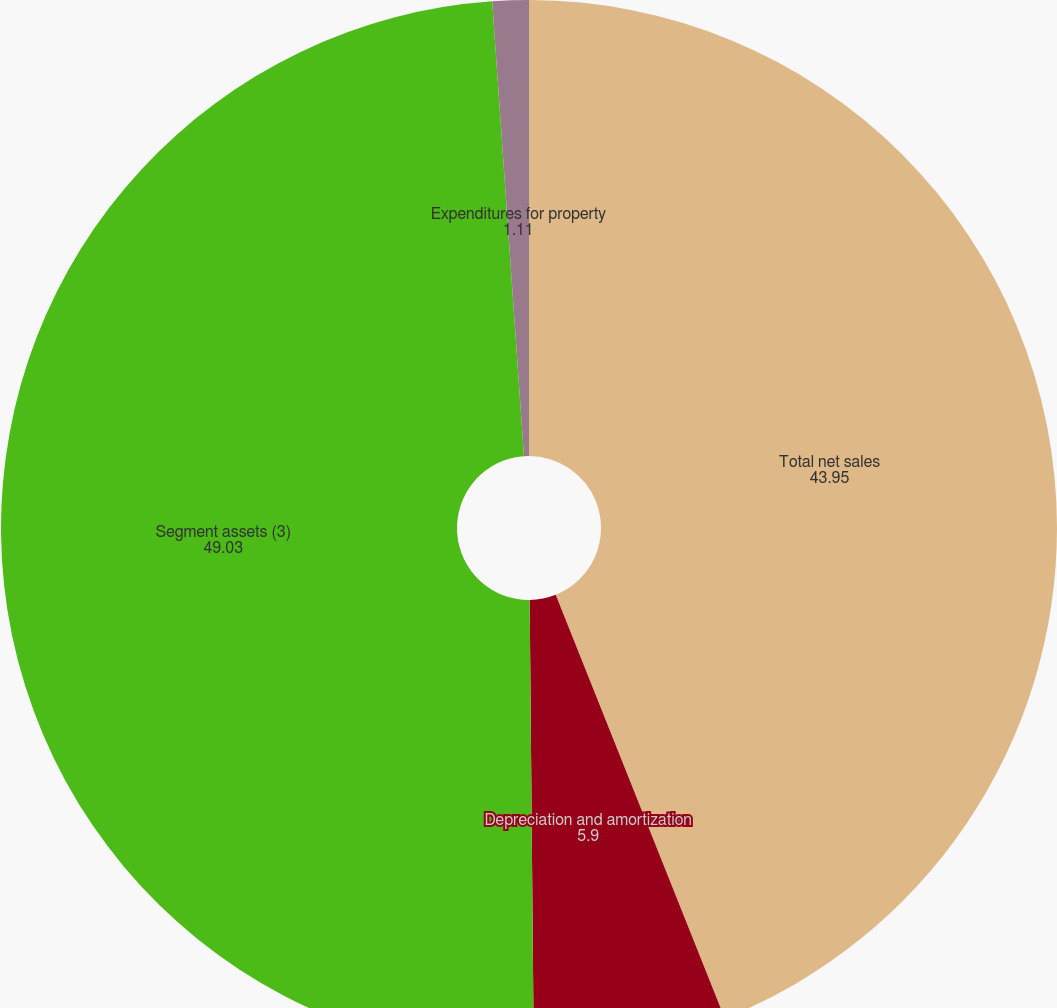<chart> <loc_0><loc_0><loc_500><loc_500><pie_chart><fcel>Total net sales<fcel>Depreciation and amortization<fcel>Segment assets (3)<fcel>Expenditures for property<nl><fcel>43.95%<fcel>5.9%<fcel>49.03%<fcel>1.11%<nl></chart> 